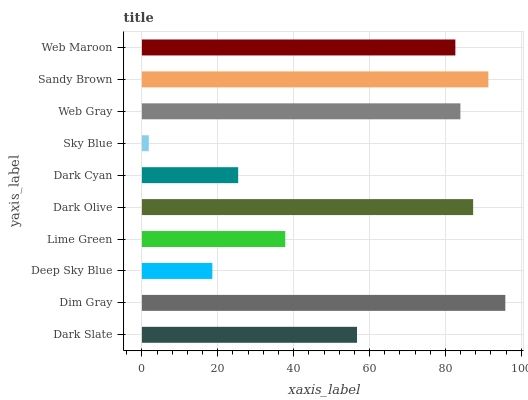Is Sky Blue the minimum?
Answer yes or no. Yes. Is Dim Gray the maximum?
Answer yes or no. Yes. Is Deep Sky Blue the minimum?
Answer yes or no. No. Is Deep Sky Blue the maximum?
Answer yes or no. No. Is Dim Gray greater than Deep Sky Blue?
Answer yes or no. Yes. Is Deep Sky Blue less than Dim Gray?
Answer yes or no. Yes. Is Deep Sky Blue greater than Dim Gray?
Answer yes or no. No. Is Dim Gray less than Deep Sky Blue?
Answer yes or no. No. Is Web Maroon the high median?
Answer yes or no. Yes. Is Dark Slate the low median?
Answer yes or no. Yes. Is Sky Blue the high median?
Answer yes or no. No. Is Dark Cyan the low median?
Answer yes or no. No. 